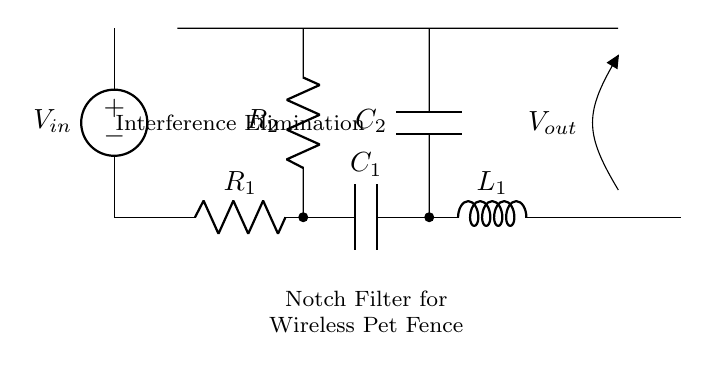What is the input voltage of the circuit? The input voltage is denoted as V_in, which represents the voltage source connected at the beginning of the circuit.
Answer: V_in What does the C symbol represent in the circuit? The C symbol in the circuit diagram indicates a capacitor, which is one of the components of the notch filter used for filtering signals.
Answer: Capacitor How many resistors are in the circuit? There are two resistors present in the circuit, R_1 and R_2, which are labeled accordingly.
Answer: 2 Which component is used for inductance? The component labeled L_1 in the circuit represents an inductor, which is used to impact the frequency characteristics of the notch filter.
Answer: Inductor What is the function of this circuit? The circuit is designed as a notch filter specifically for eliminating interference in wireless pet fence systems by attenuating unwanted frequencies.
Answer: Interference Elimination What is the output voltage denoted as? The output voltage is denoted as V_out, which is indicated at the end of the circuit where the output signal is measured or connected.
Answer: V_out What type of filter is depicted in the circuit? The circuit is a notch filter, which specifically targets and eliminates certain frequency components while allowing others to pass.
Answer: Notch Filter 